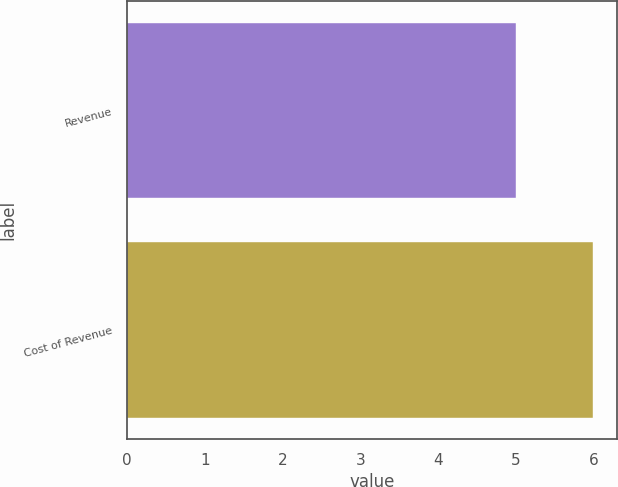Convert chart to OTSL. <chart><loc_0><loc_0><loc_500><loc_500><bar_chart><fcel>Revenue<fcel>Cost of Revenue<nl><fcel>5<fcel>6<nl></chart> 